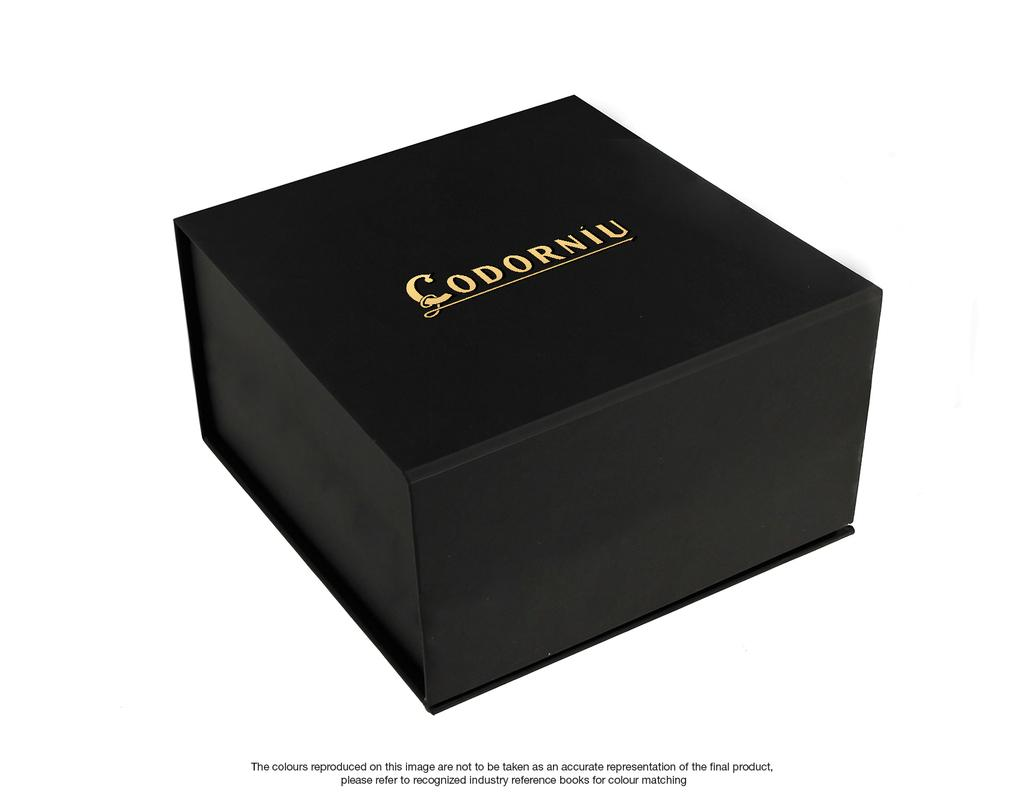Provide a one-sentence caption for the provided image. A black box that contains a Codorniu product. 